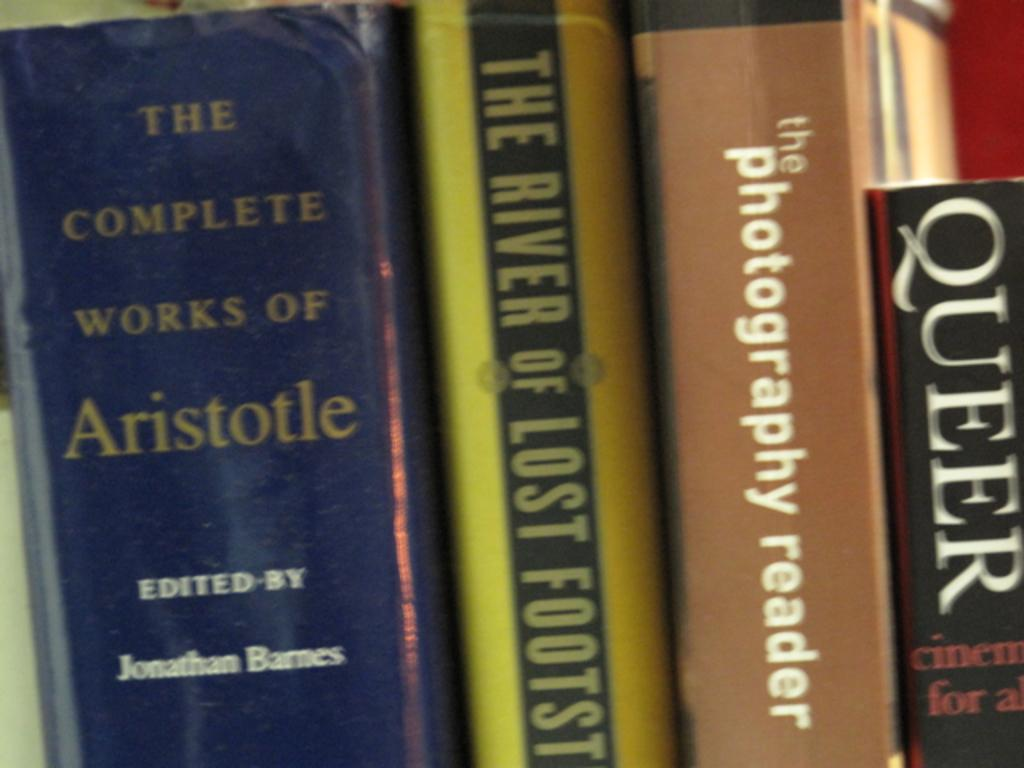<image>
Offer a succinct explanation of the picture presented. books on a shelf including Queer and Aristotle 